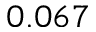Convert formula to latex. <formula><loc_0><loc_0><loc_500><loc_500>0 . 0 6 7</formula> 